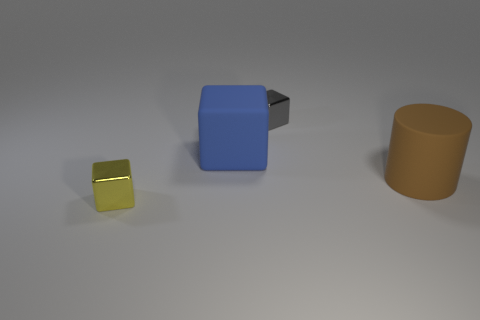Add 2 large brown matte objects. How many objects exist? 6 Subtract all blocks. How many objects are left? 1 Subtract all blue rubber balls. Subtract all big blue objects. How many objects are left? 3 Add 1 yellow metallic objects. How many yellow metallic objects are left? 2 Add 2 blue rubber objects. How many blue rubber objects exist? 3 Subtract 0 purple balls. How many objects are left? 4 